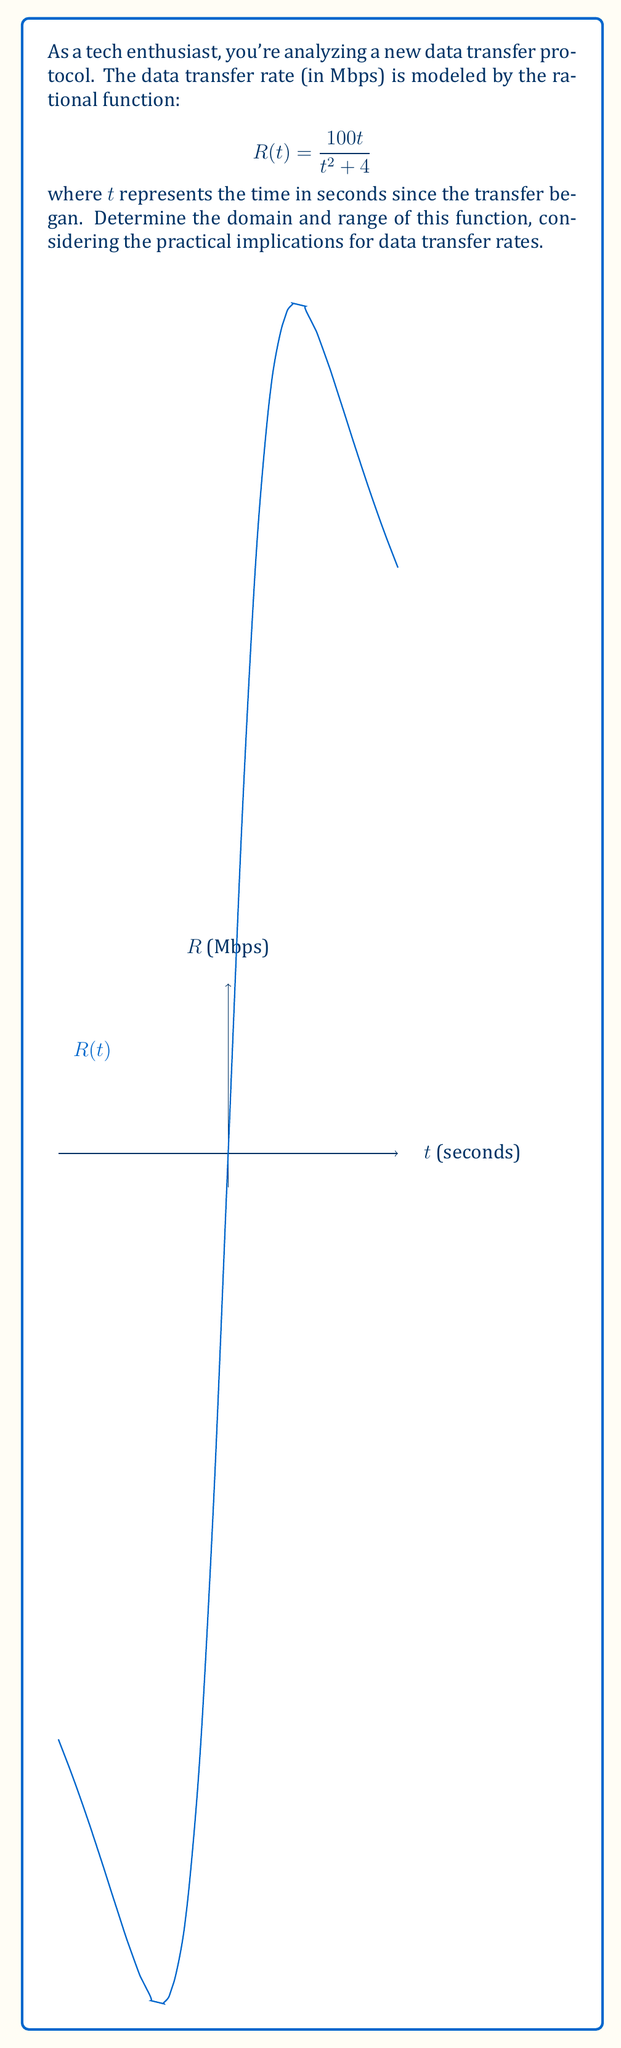Help me with this question. Let's approach this step-by-step:

1) Domain:
   The domain is all real numbers except those that make the denominator zero.
   $$t^2 + 4 = 0$$
   $$t^2 = -4$$
   This equation has no real solutions because a squared number can't be negative.
   Therefore, the domain is all real numbers: $(-\infty, \infty)$

2) Range:
   To find the range, let's analyze the function:
   
   a) As $t$ approaches $\pm\infty$, $R(t)$ approaches 0 (the horizontal asymptote).
   
   b) To find the maximum value, we can differentiate:
      $$R'(t) = \frac{(t^2+4)(100) - 100t(2t)}{(t^2+4)^2} = \frac{400-100t^2}{(t^2+4)^2}$$
   
   c) Set $R'(t) = 0$:
      $$400-100t^2 = 0$$
      $$t^2 = 4$$
      $$t = \pm 2$$
   
   d) The maximum occurs at $t = \pm 2$. Let's calculate $R(2)$:
      $$R(2) = \frac{100(2)}{2^2 + 4} = \frac{200}{8} = 25$$

Therefore, the range is $(0, 25]$, meaning the data transfer rate is always positive and never exceeds 25 Mbps.
Answer: Domain: $(-\infty, \infty)$, Range: $(0, 25]$ 